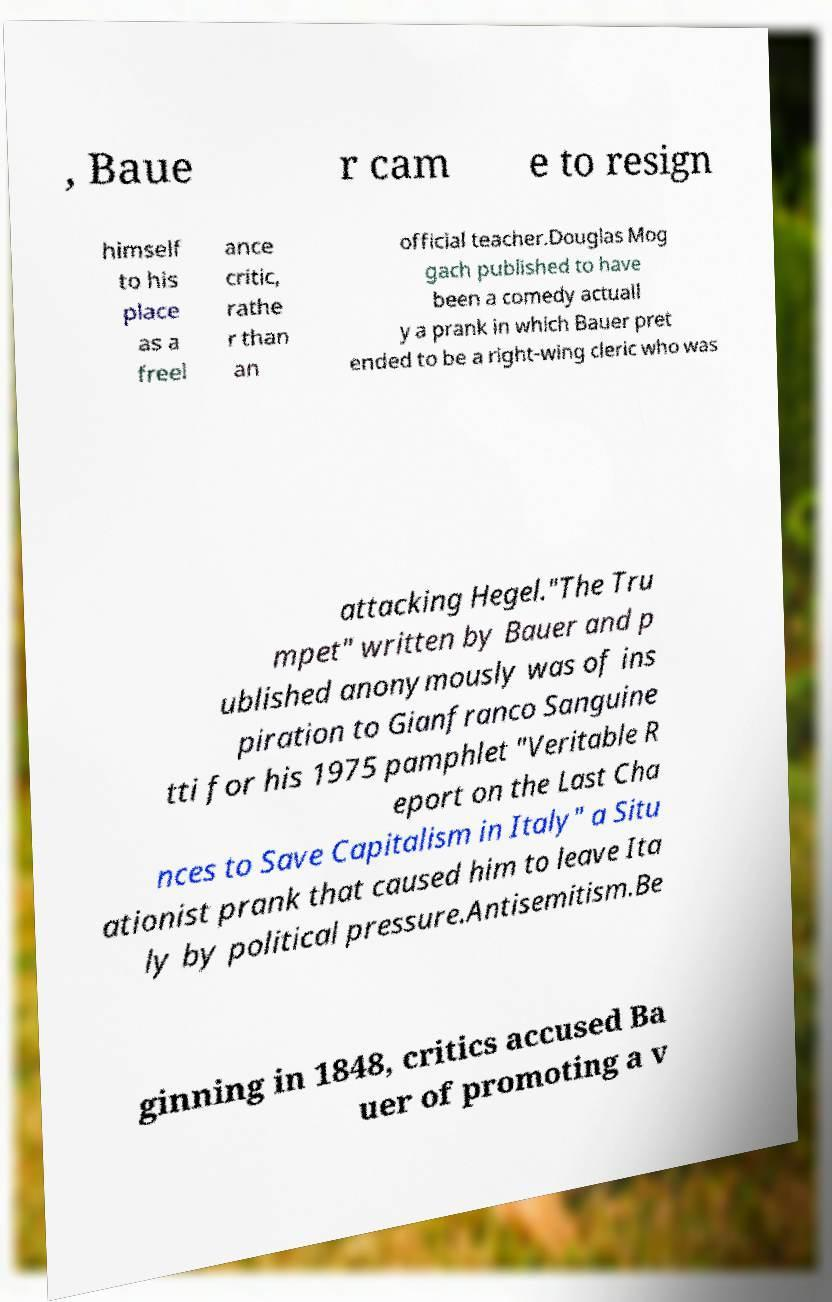I need the written content from this picture converted into text. Can you do that? , Baue r cam e to resign himself to his place as a freel ance critic, rathe r than an official teacher.Douglas Mog gach published to have been a comedy actuall y a prank in which Bauer pret ended to be a right-wing cleric who was attacking Hegel."The Tru mpet" written by Bauer and p ublished anonymously was of ins piration to Gianfranco Sanguine tti for his 1975 pamphlet "Veritable R eport on the Last Cha nces to Save Capitalism in Italy" a Situ ationist prank that caused him to leave Ita ly by political pressure.Antisemitism.Be ginning in 1848, critics accused Ba uer of promoting a v 